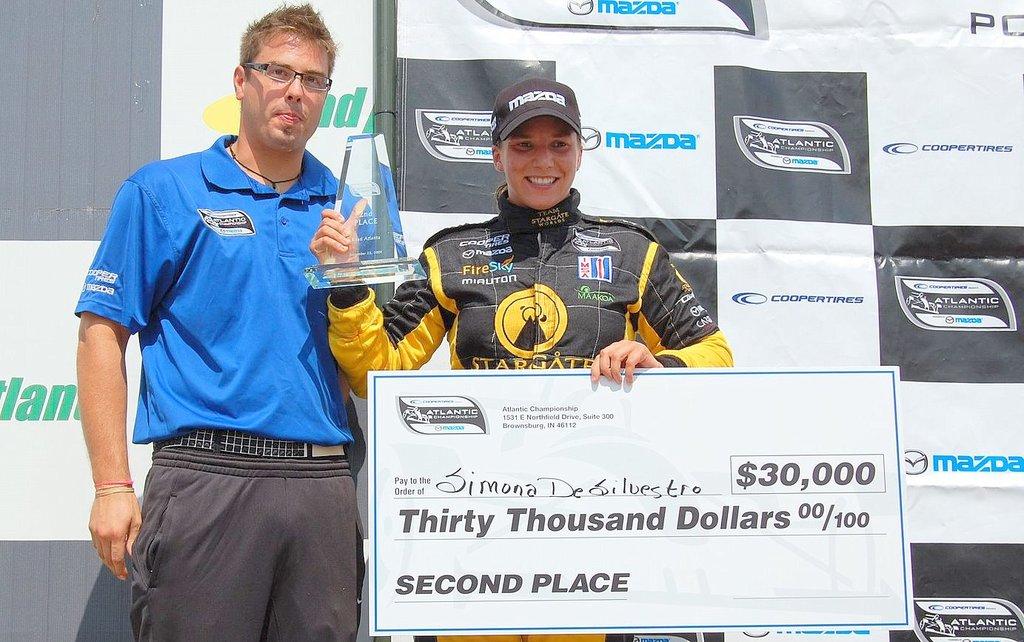Did she win thirty thousand dollars?
Provide a succinct answer. Yes. 